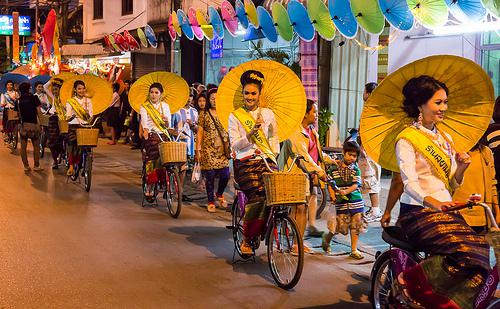Question: what are the bikes having?
Choices:
A. Bells.
B. Noisemakers.
C. Car seats.
D. Baskets.
Answer with the letter. Answer: D Question: what is below the bike?
Choices:
A. Dirt.
B. Gravel.
C. Pavement.
D. Shadow.
Answer with the letter. Answer: D Question: where was the pic taken?
Choices:
A. In a yard.
B. On the sidewalk.
C. Next to the house.
D. On the street.
Answer with the letter. Answer: D 